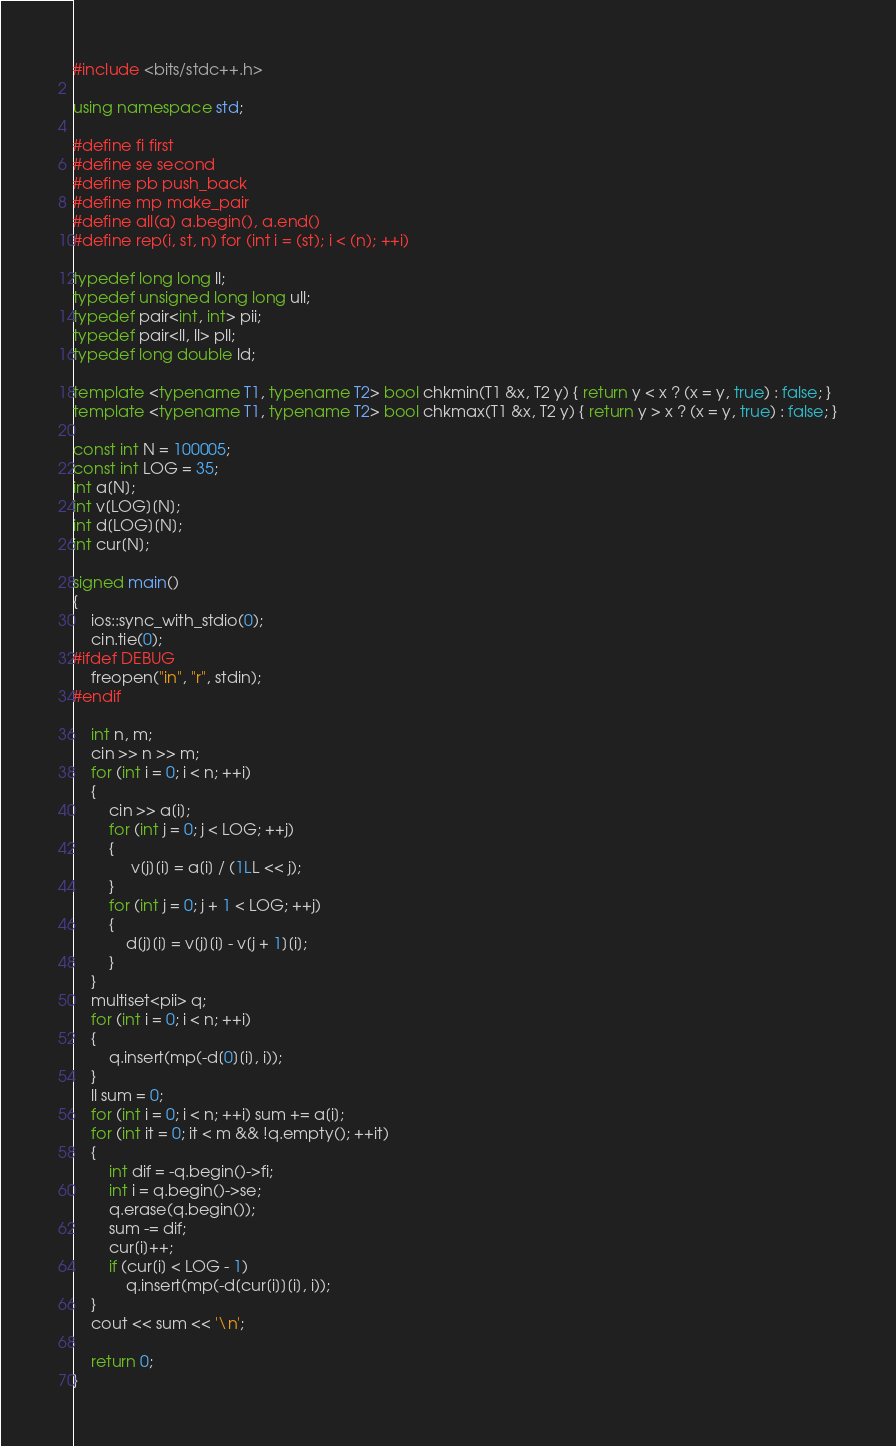Convert code to text. <code><loc_0><loc_0><loc_500><loc_500><_C++_>#include <bits/stdc++.h>
 
using namespace std;
 
#define fi first
#define se second
#define pb push_back
#define mp make_pair
#define all(a) a.begin(), a.end()
#define rep(i, st, n) for (int i = (st); i < (n); ++i)
 
typedef long long ll;
typedef unsigned long long ull;
typedef pair<int, int> pii;
typedef pair<ll, ll> pll;
typedef long double ld;
 
template <typename T1, typename T2> bool chkmin(T1 &x, T2 y) { return y < x ? (x = y, true) : false; }
template <typename T1, typename T2> bool chkmax(T1 &x, T2 y) { return y > x ? (x = y, true) : false; }

const int N = 100005;
const int LOG = 35;
int a[N];
int v[LOG][N];
int d[LOG][N];
int cur[N];

signed main()
{
    ios::sync_with_stdio(0);
    cin.tie(0);
#ifdef DEBUG
    freopen("in", "r", stdin);
#endif
    
    int n, m;
    cin >> n >> m;
    for (int i = 0; i < n; ++i)
    {
        cin >> a[i];
        for (int j = 0; j < LOG; ++j)
        {
             v[j][i] = a[i] / (1LL << j);
        }
        for (int j = 0; j + 1 < LOG; ++j)
        {
            d[j][i] = v[j][i] - v[j + 1][i];
        }
    }
    multiset<pii> q;
    for (int i = 0; i < n; ++i)
    {
        q.insert(mp(-d[0][i], i));
    }
    ll sum = 0;
    for (int i = 0; i < n; ++i) sum += a[i];
    for (int it = 0; it < m && !q.empty(); ++it)
    {
        int dif = -q.begin()->fi;
        int i = q.begin()->se;
        q.erase(q.begin());
        sum -= dif;
        cur[i]++;
        if (cur[i] < LOG - 1)
            q.insert(mp(-d[cur[i]][i], i));
    }
    cout << sum << '\n';

    return 0;
}</code> 